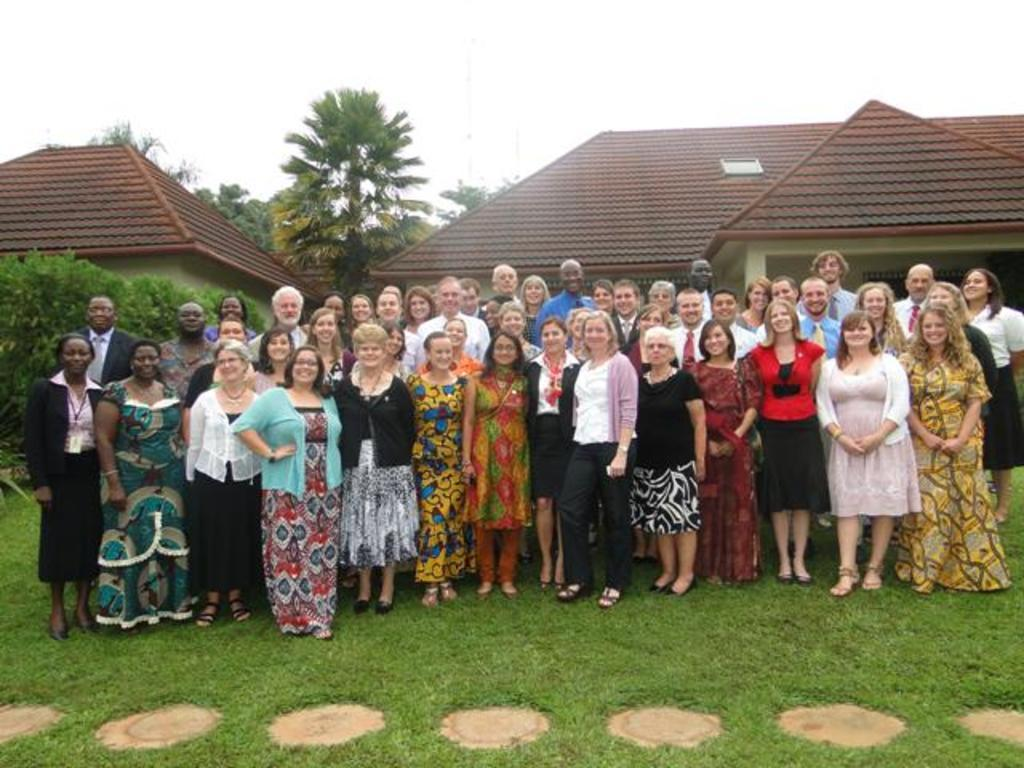How many people are in the image? There are men and a woman in the image, making a total of four people. What are the people doing in the image? The people are standing on the grass and smiling. What can be seen in the background of the image? There are houses, trees, and the sky visible in the background of the image. What type of temper does the crook have in the image? There is no crook present in the image, so it is not possible to determine their temper. 